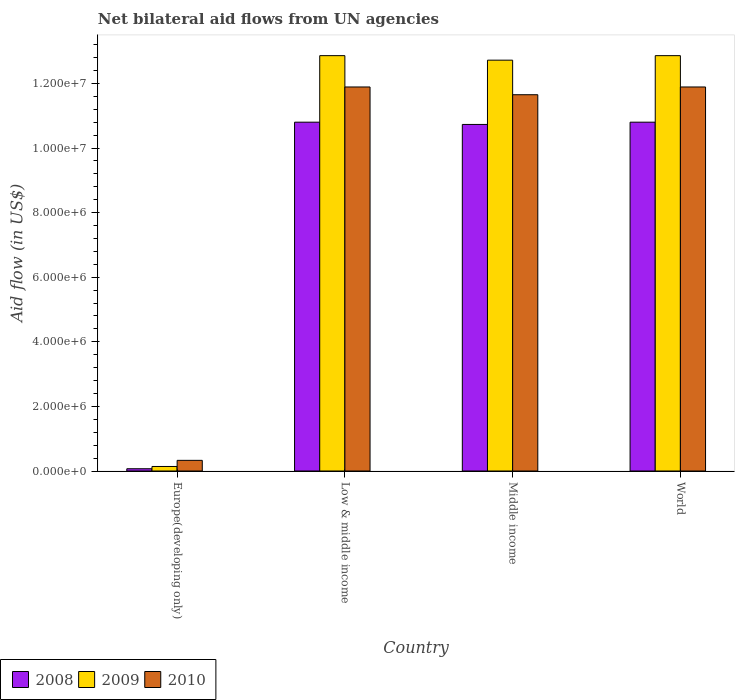How many different coloured bars are there?
Offer a terse response. 3. How many groups of bars are there?
Your answer should be very brief. 4. Are the number of bars per tick equal to the number of legend labels?
Offer a very short reply. Yes. How many bars are there on the 4th tick from the left?
Keep it short and to the point. 3. How many bars are there on the 2nd tick from the right?
Make the answer very short. 3. What is the label of the 3rd group of bars from the left?
Provide a short and direct response. Middle income. What is the net bilateral aid flow in 2008 in Low & middle income?
Provide a short and direct response. 1.08e+07. Across all countries, what is the maximum net bilateral aid flow in 2008?
Your answer should be very brief. 1.08e+07. Across all countries, what is the minimum net bilateral aid flow in 2010?
Provide a short and direct response. 3.30e+05. In which country was the net bilateral aid flow in 2009 minimum?
Keep it short and to the point. Europe(developing only). What is the total net bilateral aid flow in 2009 in the graph?
Give a very brief answer. 3.86e+07. What is the difference between the net bilateral aid flow in 2010 in Europe(developing only) and that in World?
Your answer should be compact. -1.16e+07. What is the difference between the net bilateral aid flow in 2008 in Low & middle income and the net bilateral aid flow in 2010 in Middle income?
Keep it short and to the point. -8.50e+05. What is the average net bilateral aid flow in 2010 per country?
Give a very brief answer. 8.94e+06. What is the difference between the net bilateral aid flow of/in 2008 and net bilateral aid flow of/in 2009 in Middle income?
Your answer should be compact. -1.99e+06. Is the difference between the net bilateral aid flow in 2008 in Europe(developing only) and Low & middle income greater than the difference between the net bilateral aid flow in 2009 in Europe(developing only) and Low & middle income?
Provide a short and direct response. Yes. What is the difference between the highest and the second highest net bilateral aid flow in 2010?
Offer a terse response. 2.40e+05. What is the difference between the highest and the lowest net bilateral aid flow in 2008?
Provide a succinct answer. 1.07e+07. In how many countries, is the net bilateral aid flow in 2008 greater than the average net bilateral aid flow in 2008 taken over all countries?
Provide a short and direct response. 3. Is the sum of the net bilateral aid flow in 2010 in Low & middle income and Middle income greater than the maximum net bilateral aid flow in 2009 across all countries?
Ensure brevity in your answer.  Yes. What does the 1st bar from the left in Low & middle income represents?
Provide a short and direct response. 2008. What does the 3rd bar from the right in Low & middle income represents?
Offer a terse response. 2008. Is it the case that in every country, the sum of the net bilateral aid flow in 2010 and net bilateral aid flow in 2008 is greater than the net bilateral aid flow in 2009?
Make the answer very short. Yes. Does the graph contain any zero values?
Make the answer very short. No. Does the graph contain grids?
Your response must be concise. No. How many legend labels are there?
Offer a terse response. 3. What is the title of the graph?
Keep it short and to the point. Net bilateral aid flows from UN agencies. Does "1972" appear as one of the legend labels in the graph?
Your answer should be compact. No. What is the label or title of the Y-axis?
Offer a terse response. Aid flow (in US$). What is the Aid flow (in US$) in 2010 in Europe(developing only)?
Your answer should be compact. 3.30e+05. What is the Aid flow (in US$) in 2008 in Low & middle income?
Offer a very short reply. 1.08e+07. What is the Aid flow (in US$) in 2009 in Low & middle income?
Offer a very short reply. 1.29e+07. What is the Aid flow (in US$) of 2010 in Low & middle income?
Provide a succinct answer. 1.19e+07. What is the Aid flow (in US$) of 2008 in Middle income?
Provide a short and direct response. 1.07e+07. What is the Aid flow (in US$) of 2009 in Middle income?
Keep it short and to the point. 1.27e+07. What is the Aid flow (in US$) of 2010 in Middle income?
Make the answer very short. 1.16e+07. What is the Aid flow (in US$) in 2008 in World?
Ensure brevity in your answer.  1.08e+07. What is the Aid flow (in US$) of 2009 in World?
Ensure brevity in your answer.  1.29e+07. What is the Aid flow (in US$) in 2010 in World?
Offer a terse response. 1.19e+07. Across all countries, what is the maximum Aid flow (in US$) in 2008?
Ensure brevity in your answer.  1.08e+07. Across all countries, what is the maximum Aid flow (in US$) in 2009?
Offer a very short reply. 1.29e+07. Across all countries, what is the maximum Aid flow (in US$) of 2010?
Offer a very short reply. 1.19e+07. Across all countries, what is the minimum Aid flow (in US$) in 2008?
Your response must be concise. 7.00e+04. Across all countries, what is the minimum Aid flow (in US$) in 2009?
Make the answer very short. 1.40e+05. Across all countries, what is the minimum Aid flow (in US$) in 2010?
Your response must be concise. 3.30e+05. What is the total Aid flow (in US$) of 2008 in the graph?
Keep it short and to the point. 3.24e+07. What is the total Aid flow (in US$) in 2009 in the graph?
Provide a succinct answer. 3.86e+07. What is the total Aid flow (in US$) in 2010 in the graph?
Your answer should be compact. 3.58e+07. What is the difference between the Aid flow (in US$) of 2008 in Europe(developing only) and that in Low & middle income?
Keep it short and to the point. -1.07e+07. What is the difference between the Aid flow (in US$) of 2009 in Europe(developing only) and that in Low & middle income?
Ensure brevity in your answer.  -1.27e+07. What is the difference between the Aid flow (in US$) in 2010 in Europe(developing only) and that in Low & middle income?
Offer a very short reply. -1.16e+07. What is the difference between the Aid flow (in US$) of 2008 in Europe(developing only) and that in Middle income?
Ensure brevity in your answer.  -1.07e+07. What is the difference between the Aid flow (in US$) of 2009 in Europe(developing only) and that in Middle income?
Give a very brief answer. -1.26e+07. What is the difference between the Aid flow (in US$) of 2010 in Europe(developing only) and that in Middle income?
Your answer should be compact. -1.13e+07. What is the difference between the Aid flow (in US$) of 2008 in Europe(developing only) and that in World?
Your response must be concise. -1.07e+07. What is the difference between the Aid flow (in US$) in 2009 in Europe(developing only) and that in World?
Keep it short and to the point. -1.27e+07. What is the difference between the Aid flow (in US$) of 2010 in Europe(developing only) and that in World?
Offer a terse response. -1.16e+07. What is the difference between the Aid flow (in US$) of 2009 in Low & middle income and that in Middle income?
Your answer should be very brief. 1.40e+05. What is the difference between the Aid flow (in US$) in 2010 in Low & middle income and that in Middle income?
Keep it short and to the point. 2.40e+05. What is the difference between the Aid flow (in US$) in 2010 in Low & middle income and that in World?
Ensure brevity in your answer.  0. What is the difference between the Aid flow (in US$) in 2008 in Middle income and that in World?
Ensure brevity in your answer.  -7.00e+04. What is the difference between the Aid flow (in US$) of 2008 in Europe(developing only) and the Aid flow (in US$) of 2009 in Low & middle income?
Your answer should be compact. -1.28e+07. What is the difference between the Aid flow (in US$) of 2008 in Europe(developing only) and the Aid flow (in US$) of 2010 in Low & middle income?
Provide a succinct answer. -1.18e+07. What is the difference between the Aid flow (in US$) in 2009 in Europe(developing only) and the Aid flow (in US$) in 2010 in Low & middle income?
Keep it short and to the point. -1.18e+07. What is the difference between the Aid flow (in US$) in 2008 in Europe(developing only) and the Aid flow (in US$) in 2009 in Middle income?
Your answer should be very brief. -1.26e+07. What is the difference between the Aid flow (in US$) in 2008 in Europe(developing only) and the Aid flow (in US$) in 2010 in Middle income?
Offer a terse response. -1.16e+07. What is the difference between the Aid flow (in US$) of 2009 in Europe(developing only) and the Aid flow (in US$) of 2010 in Middle income?
Your answer should be very brief. -1.15e+07. What is the difference between the Aid flow (in US$) in 2008 in Europe(developing only) and the Aid flow (in US$) in 2009 in World?
Your answer should be very brief. -1.28e+07. What is the difference between the Aid flow (in US$) of 2008 in Europe(developing only) and the Aid flow (in US$) of 2010 in World?
Offer a terse response. -1.18e+07. What is the difference between the Aid flow (in US$) in 2009 in Europe(developing only) and the Aid flow (in US$) in 2010 in World?
Your response must be concise. -1.18e+07. What is the difference between the Aid flow (in US$) of 2008 in Low & middle income and the Aid flow (in US$) of 2009 in Middle income?
Offer a terse response. -1.92e+06. What is the difference between the Aid flow (in US$) in 2008 in Low & middle income and the Aid flow (in US$) in 2010 in Middle income?
Make the answer very short. -8.50e+05. What is the difference between the Aid flow (in US$) of 2009 in Low & middle income and the Aid flow (in US$) of 2010 in Middle income?
Provide a short and direct response. 1.21e+06. What is the difference between the Aid flow (in US$) in 2008 in Low & middle income and the Aid flow (in US$) in 2009 in World?
Provide a succinct answer. -2.06e+06. What is the difference between the Aid flow (in US$) in 2008 in Low & middle income and the Aid flow (in US$) in 2010 in World?
Your response must be concise. -1.09e+06. What is the difference between the Aid flow (in US$) in 2009 in Low & middle income and the Aid flow (in US$) in 2010 in World?
Keep it short and to the point. 9.70e+05. What is the difference between the Aid flow (in US$) in 2008 in Middle income and the Aid flow (in US$) in 2009 in World?
Provide a short and direct response. -2.13e+06. What is the difference between the Aid flow (in US$) of 2008 in Middle income and the Aid flow (in US$) of 2010 in World?
Give a very brief answer. -1.16e+06. What is the difference between the Aid flow (in US$) in 2009 in Middle income and the Aid flow (in US$) in 2010 in World?
Give a very brief answer. 8.30e+05. What is the average Aid flow (in US$) of 2008 per country?
Give a very brief answer. 8.10e+06. What is the average Aid flow (in US$) of 2009 per country?
Keep it short and to the point. 9.64e+06. What is the average Aid flow (in US$) of 2010 per country?
Provide a succinct answer. 8.94e+06. What is the difference between the Aid flow (in US$) of 2009 and Aid flow (in US$) of 2010 in Europe(developing only)?
Your answer should be compact. -1.90e+05. What is the difference between the Aid flow (in US$) of 2008 and Aid flow (in US$) of 2009 in Low & middle income?
Make the answer very short. -2.06e+06. What is the difference between the Aid flow (in US$) in 2008 and Aid flow (in US$) in 2010 in Low & middle income?
Your answer should be very brief. -1.09e+06. What is the difference between the Aid flow (in US$) of 2009 and Aid flow (in US$) of 2010 in Low & middle income?
Your answer should be compact. 9.70e+05. What is the difference between the Aid flow (in US$) of 2008 and Aid flow (in US$) of 2009 in Middle income?
Your answer should be very brief. -1.99e+06. What is the difference between the Aid flow (in US$) in 2008 and Aid flow (in US$) in 2010 in Middle income?
Keep it short and to the point. -9.20e+05. What is the difference between the Aid flow (in US$) in 2009 and Aid flow (in US$) in 2010 in Middle income?
Your answer should be very brief. 1.07e+06. What is the difference between the Aid flow (in US$) of 2008 and Aid flow (in US$) of 2009 in World?
Your response must be concise. -2.06e+06. What is the difference between the Aid flow (in US$) of 2008 and Aid flow (in US$) of 2010 in World?
Your response must be concise. -1.09e+06. What is the difference between the Aid flow (in US$) of 2009 and Aid flow (in US$) of 2010 in World?
Ensure brevity in your answer.  9.70e+05. What is the ratio of the Aid flow (in US$) in 2008 in Europe(developing only) to that in Low & middle income?
Your answer should be very brief. 0.01. What is the ratio of the Aid flow (in US$) in 2009 in Europe(developing only) to that in Low & middle income?
Provide a succinct answer. 0.01. What is the ratio of the Aid flow (in US$) in 2010 in Europe(developing only) to that in Low & middle income?
Give a very brief answer. 0.03. What is the ratio of the Aid flow (in US$) in 2008 in Europe(developing only) to that in Middle income?
Offer a very short reply. 0.01. What is the ratio of the Aid flow (in US$) of 2009 in Europe(developing only) to that in Middle income?
Offer a terse response. 0.01. What is the ratio of the Aid flow (in US$) in 2010 in Europe(developing only) to that in Middle income?
Ensure brevity in your answer.  0.03. What is the ratio of the Aid flow (in US$) in 2008 in Europe(developing only) to that in World?
Provide a short and direct response. 0.01. What is the ratio of the Aid flow (in US$) of 2009 in Europe(developing only) to that in World?
Your answer should be very brief. 0.01. What is the ratio of the Aid flow (in US$) of 2010 in Europe(developing only) to that in World?
Offer a very short reply. 0.03. What is the ratio of the Aid flow (in US$) of 2009 in Low & middle income to that in Middle income?
Ensure brevity in your answer.  1.01. What is the ratio of the Aid flow (in US$) in 2010 in Low & middle income to that in Middle income?
Offer a terse response. 1.02. What is the ratio of the Aid flow (in US$) of 2008 in Low & middle income to that in World?
Offer a terse response. 1. What is the ratio of the Aid flow (in US$) in 2009 in Middle income to that in World?
Your answer should be very brief. 0.99. What is the ratio of the Aid flow (in US$) of 2010 in Middle income to that in World?
Make the answer very short. 0.98. What is the difference between the highest and the second highest Aid flow (in US$) of 2008?
Your answer should be very brief. 0. What is the difference between the highest and the second highest Aid flow (in US$) in 2009?
Your response must be concise. 0. What is the difference between the highest and the lowest Aid flow (in US$) in 2008?
Make the answer very short. 1.07e+07. What is the difference between the highest and the lowest Aid flow (in US$) in 2009?
Make the answer very short. 1.27e+07. What is the difference between the highest and the lowest Aid flow (in US$) of 2010?
Offer a very short reply. 1.16e+07. 